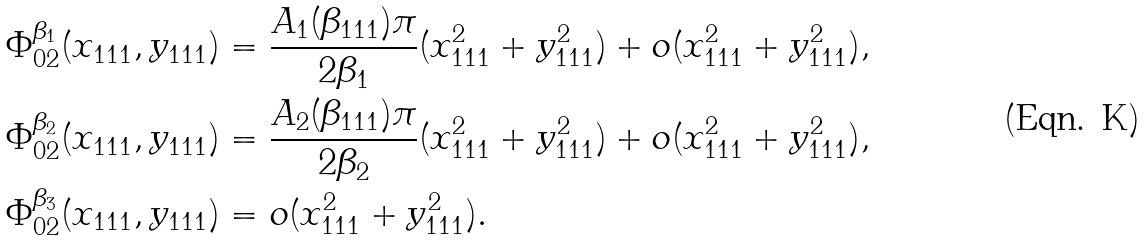<formula> <loc_0><loc_0><loc_500><loc_500>& \Phi _ { 0 2 } ^ { \beta _ { 1 } } ( x _ { 1 1 1 } , y _ { 1 1 1 } ) = \frac { A _ { 1 } ( \beta _ { 1 1 1 } ) \pi } { 2 \beta _ { 1 } } ( x _ { 1 1 1 } ^ { 2 } + y _ { 1 1 1 } ^ { 2 } ) + o ( x _ { 1 1 1 } ^ { 2 } + y _ { 1 1 1 } ^ { 2 } ) , \\ & \Phi _ { 0 2 } ^ { \beta _ { 2 } } ( x _ { 1 1 1 } , y _ { 1 1 1 } ) = \frac { A _ { 2 } ( \beta _ { 1 1 1 } ) \pi } { 2 \beta _ { 2 } } ( x _ { 1 1 1 } ^ { 2 } + y _ { 1 1 1 } ^ { 2 } ) + o ( x _ { 1 1 1 } ^ { 2 } + y _ { 1 1 1 } ^ { 2 } ) , \\ & \Phi _ { 0 2 } ^ { \beta _ { 3 } } ( x _ { 1 1 1 } , y _ { 1 1 1 } ) = o ( x _ { 1 1 1 } ^ { 2 } + y _ { 1 1 1 } ^ { 2 } ) .</formula> 